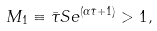Convert formula to latex. <formula><loc_0><loc_0><loc_500><loc_500>M _ { 1 } \equiv \bar { \tau } S e ^ { ( \alpha \bar { \tau } + 1 ) } > 1 ,</formula> 